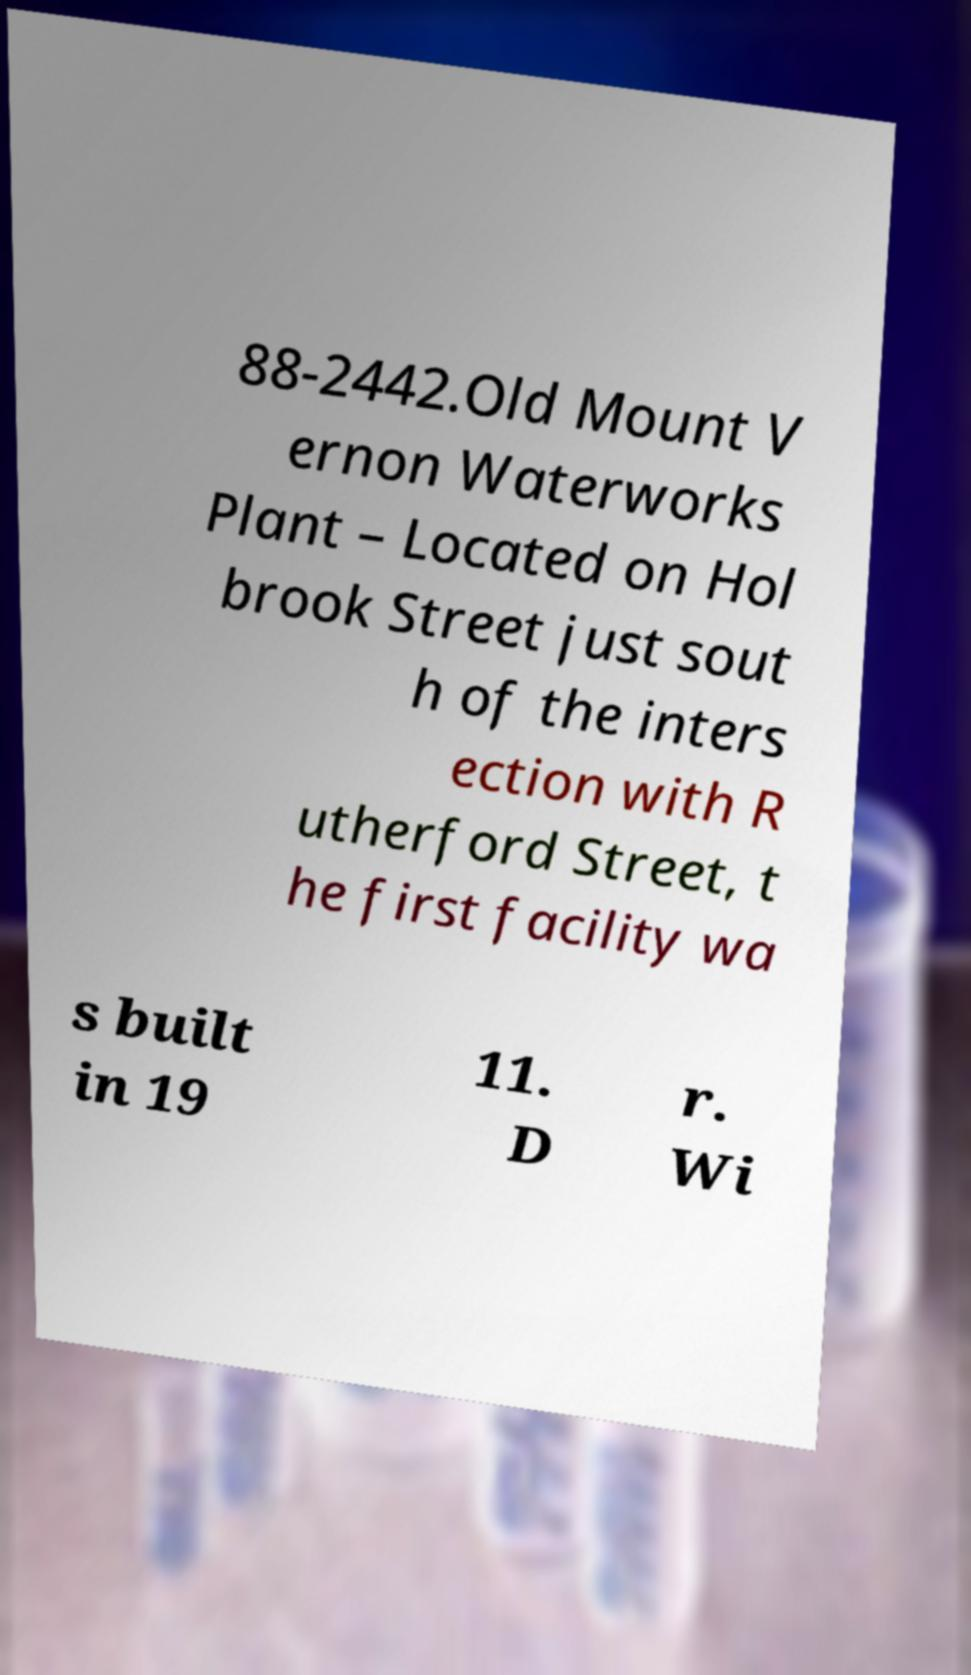Can you read and provide the text displayed in the image?This photo seems to have some interesting text. Can you extract and type it out for me? 88-2442.Old Mount V ernon Waterworks Plant – Located on Hol brook Street just sout h of the inters ection with R utherford Street, t he first facility wa s built in 19 11. D r. Wi 